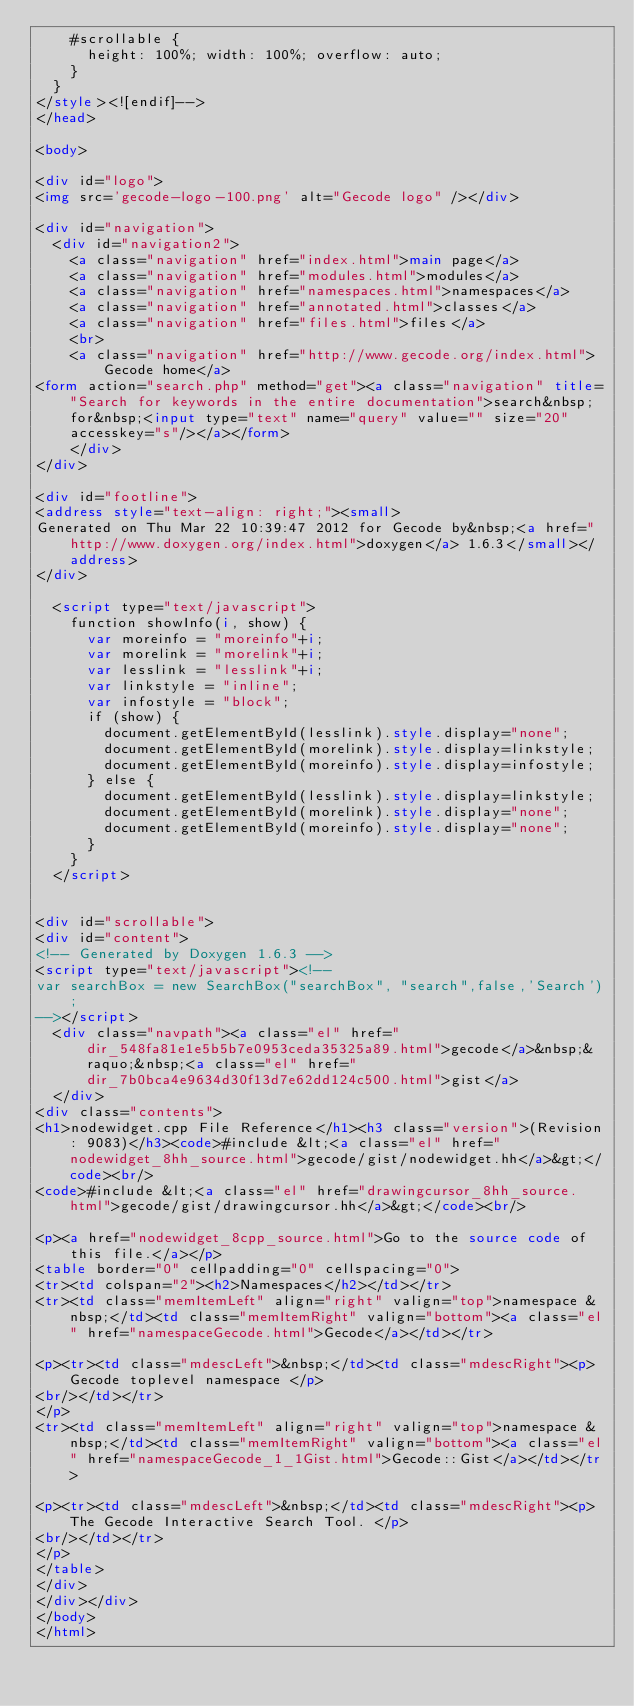Convert code to text. <code><loc_0><loc_0><loc_500><loc_500><_HTML_>    #scrollable {
      height: 100%; width: 100%; overflow: auto;
    }
  }
</style><![endif]-->
</head>

<body>

<div id="logo">
<img src='gecode-logo-100.png' alt="Gecode logo" /></div>

<div id="navigation">
  <div id="navigation2">
    <a class="navigation" href="index.html">main page</a>
    <a class="navigation" href="modules.html">modules</a>
    <a class="navigation" href="namespaces.html">namespaces</a>
    <a class="navigation" href="annotated.html">classes</a>
    <a class="navigation" href="files.html">files</a>
    <br>
    <a class="navigation" href="http://www.gecode.org/index.html">Gecode home</a>
<form action="search.php" method="get"><a class="navigation" title="Search for keywords in the entire documentation">search&nbsp;for&nbsp;<input type="text" name="query" value="" size="20" accesskey="s"/></a></form>
    </div>
</div>

<div id="footline">
<address style="text-align: right;"><small>
Generated on Thu Mar 22 10:39:47 2012 for Gecode by&nbsp;<a href="http://www.doxygen.org/index.html">doxygen</a> 1.6.3</small></address>
</div>

  <script type="text/javascript">
    function showInfo(i, show) {
      var moreinfo = "moreinfo"+i;
      var morelink = "morelink"+i;
      var lesslink = "lesslink"+i;
      var linkstyle = "inline";
      var infostyle = "block";
      if (show) {
        document.getElementById(lesslink).style.display="none";
        document.getElementById(morelink).style.display=linkstyle;
        document.getElementById(moreinfo).style.display=infostyle;
      } else {
        document.getElementById(lesslink).style.display=linkstyle;        
        document.getElementById(morelink).style.display="none";        
        document.getElementById(moreinfo).style.display="none";        
      }
    }
  </script>


<div id="scrollable">
<div id="content">
<!-- Generated by Doxygen 1.6.3 -->
<script type="text/javascript"><!--
var searchBox = new SearchBox("searchBox", "search",false,'Search');
--></script>
  <div class="navpath"><a class="el" href="dir_548fa81e1e5b5b7e0953ceda35325a89.html">gecode</a>&nbsp;&raquo;&nbsp;<a class="el" href="dir_7b0bca4e9634d30f13d7e62dd124c500.html">gist</a>
  </div>
<div class="contents">
<h1>nodewidget.cpp File Reference</h1><h3 class="version">(Revision: 9083)</h3><code>#include &lt;<a class="el" href="nodewidget_8hh_source.html">gecode/gist/nodewidget.hh</a>&gt;</code><br/>
<code>#include &lt;<a class="el" href="drawingcursor_8hh_source.html">gecode/gist/drawingcursor.hh</a>&gt;</code><br/>

<p><a href="nodewidget_8cpp_source.html">Go to the source code of this file.</a></p>
<table border="0" cellpadding="0" cellspacing="0">
<tr><td colspan="2"><h2>Namespaces</h2></td></tr>
<tr><td class="memItemLeft" align="right" valign="top">namespace &nbsp;</td><td class="memItemRight" valign="bottom"><a class="el" href="namespaceGecode.html">Gecode</a></td></tr>

<p><tr><td class="mdescLeft">&nbsp;</td><td class="mdescRight"><p>Gecode toplevel namespace </p>
<br/></td></tr>
</p>
<tr><td class="memItemLeft" align="right" valign="top">namespace &nbsp;</td><td class="memItemRight" valign="bottom"><a class="el" href="namespaceGecode_1_1Gist.html">Gecode::Gist</a></td></tr>

<p><tr><td class="mdescLeft">&nbsp;</td><td class="mdescRight"><p>The Gecode Interactive Search Tool. </p>
<br/></td></tr>
</p>
</table>
</div>
</div></div>
</body>
</html>
</code> 